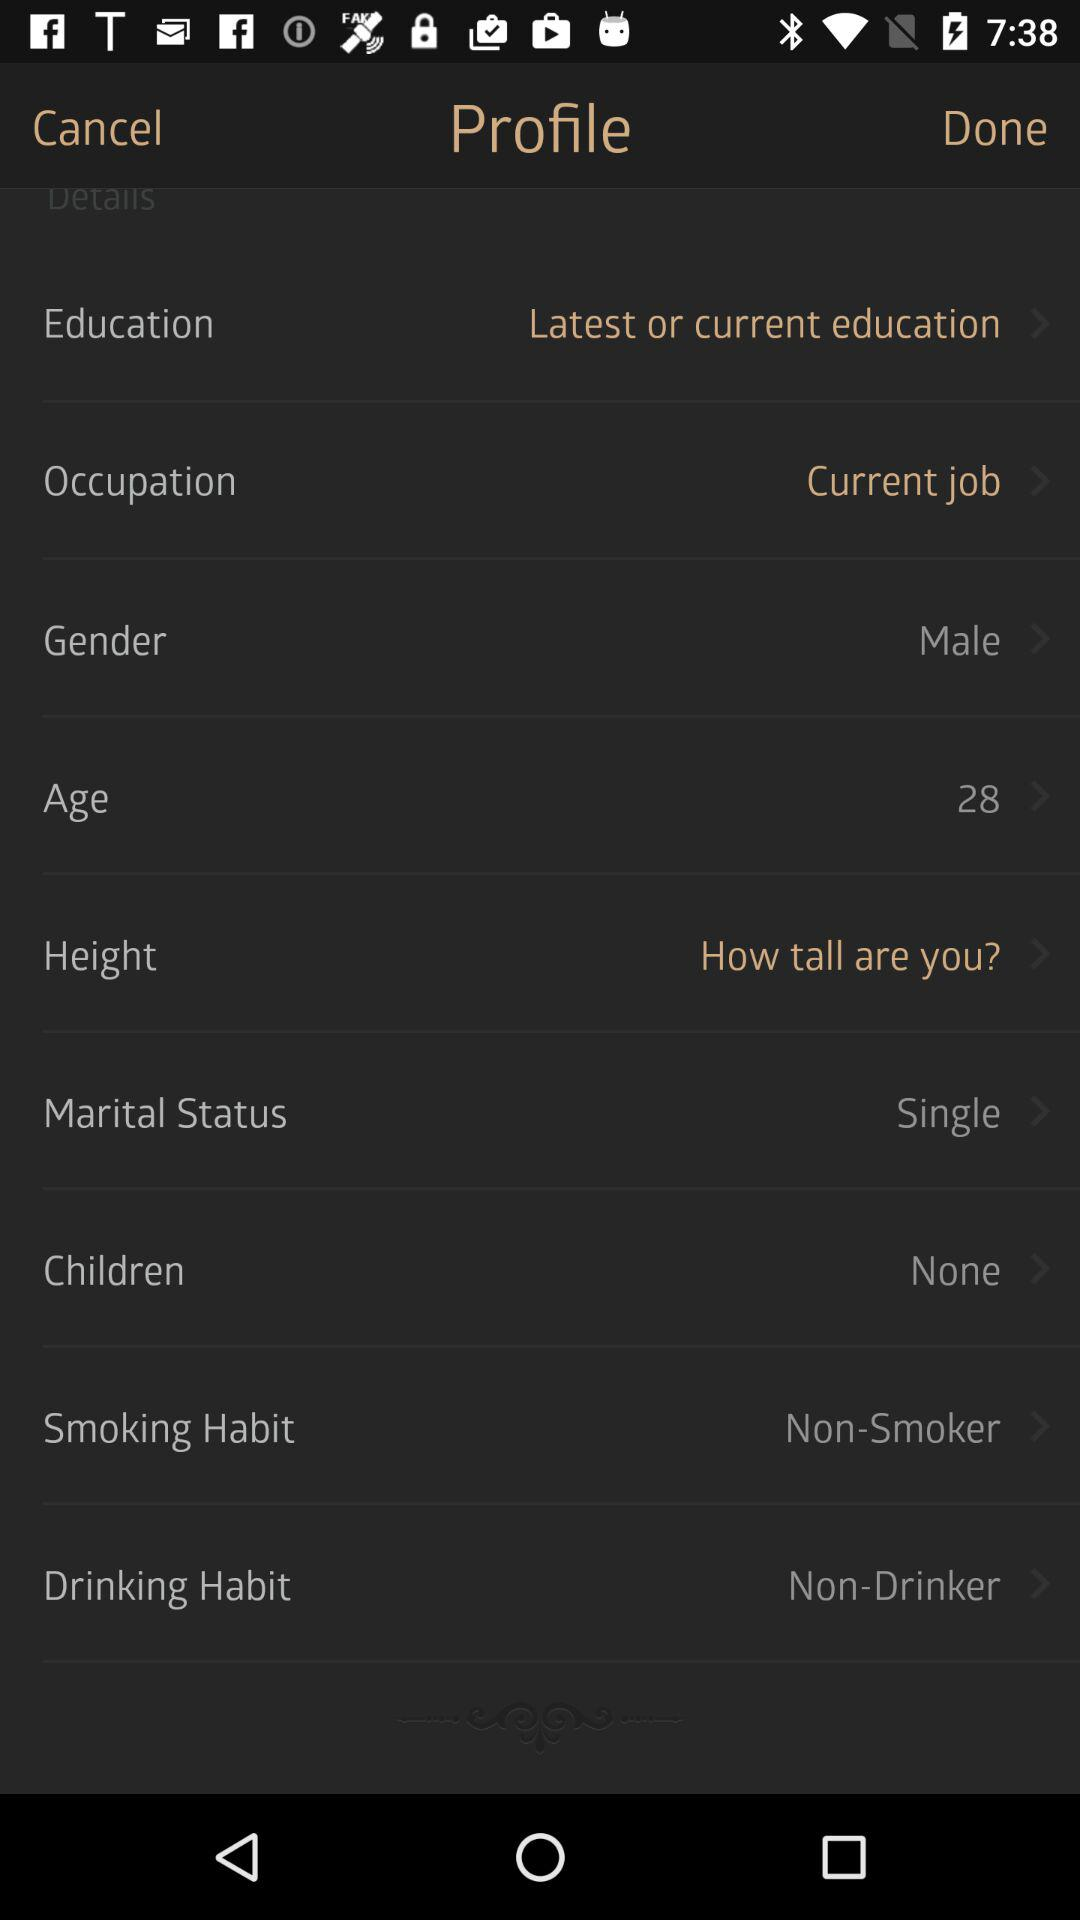What is the gender of the person? The gender is male. 